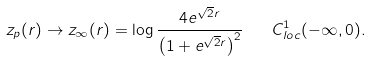<formula> <loc_0><loc_0><loc_500><loc_500>z _ { p } ( r ) \to z _ { \infty } ( r ) = \log \frac { 4 e ^ { \sqrt { 2 } r } } { \left ( 1 + e ^ { \sqrt { 2 } r } \right ) ^ { 2 } } \quad C ^ { 1 } _ { l o c } ( - \infty , 0 ) .</formula> 